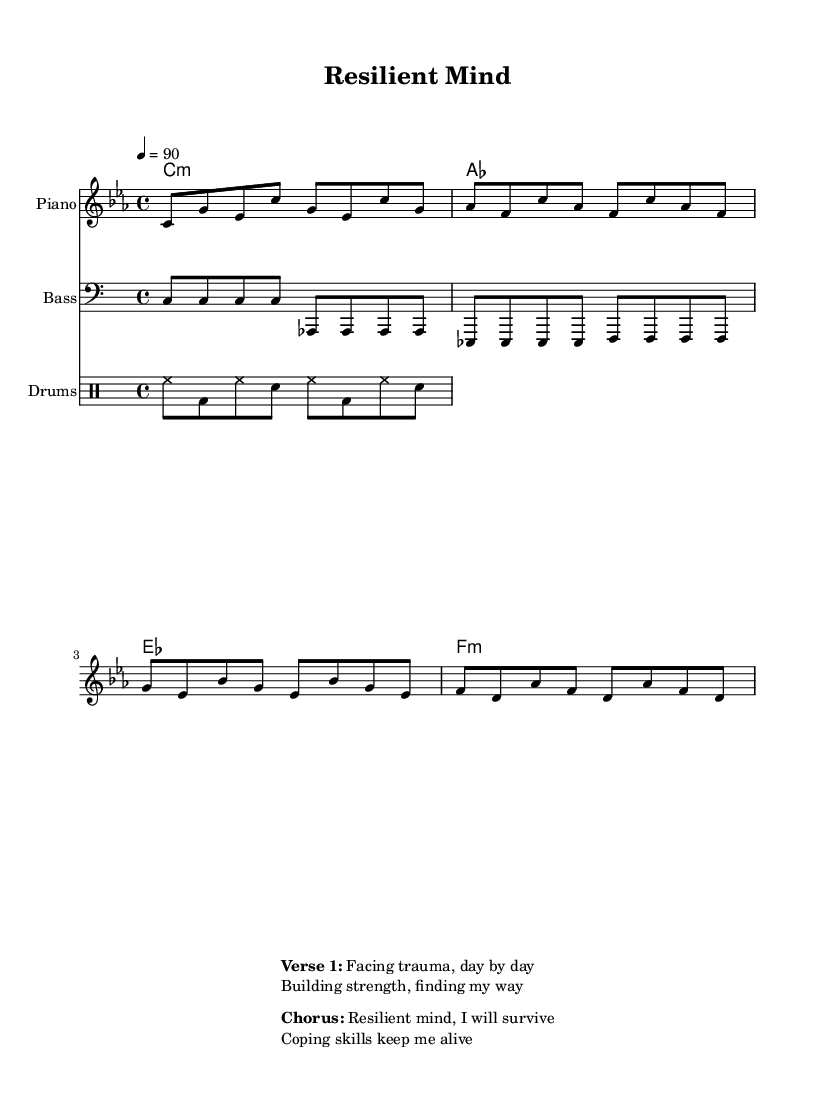What is the key signature of this music? The key signature is C minor, which consists of three flats (B♭, E♭, A♭). This is indicated at the beginning of the score, where the key signature is notated.
Answer: C minor What is the time signature of this music? The time signature is 4/4, which means there are four beats in each measure and each quarter note gets one beat. This is shown at the beginning after the clef and the key signature.
Answer: 4/4 What is the tempo marking for this piece? The tempo marking is 90 beats per minute, indicated by the "4 = 90" notation, which tells the performer the speed at which to play the piece.
Answer: 90 What is the structure of the lyrical content provided? The structure consists of a verse followed by a chorus, as indicated by the labels in the markup section. The verse focuses on facing trauma, while the chorus emphasizes resilience and coping skills.
Answer: Verse and Chorus How many unique sections are there in the lyrical content? There are two distinct sections, which are the verse and the chorus. This is evident from the labeled lines in the markup section, which show a clear division between the two.
Answer: Two What genre does this piece of music represent? The music represents the hip hop genre, which is evident from its style and lyrical content focused on themes of mental health resilience and coping strategies. The structure and rhythmic element also align with hip hop characteristics.
Answer: Hip hop What is the primary theme explored in the lyrics? The primary theme explored in the lyrics is mental health resilience, as the lines focus on facing trauma and the importance of coping skills, indicating a strong message about overcoming difficulties.
Answer: Mental health resilience 